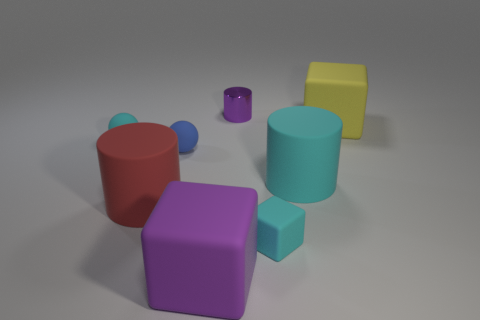The cyan rubber object that is the same shape as the yellow matte object is what size?
Ensure brevity in your answer.  Small. What number of other things are made of the same material as the large cyan object?
Give a very brief answer. 6. Do the tiny blue thing and the big object behind the cyan ball have the same material?
Your answer should be compact. Yes. Is the number of large purple blocks that are right of the small cyan ball less than the number of big cylinders that are on the left side of the yellow rubber thing?
Offer a terse response. Yes. The thing that is behind the yellow object is what color?
Make the answer very short. Purple. What number of other objects are the same color as the tiny rubber cube?
Your answer should be very brief. 2. Does the thing behind the yellow matte thing have the same size as the large red object?
Provide a short and direct response. No. What number of tiny cubes are behind the metal cylinder?
Offer a very short reply. 0. Are there any purple rubber things of the same size as the red rubber thing?
Offer a terse response. Yes. The cylinder that is behind the big matte block to the right of the large purple matte thing is what color?
Your response must be concise. Purple. 